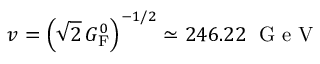Convert formula to latex. <formula><loc_0><loc_0><loc_500><loc_500>v = \left ( { \sqrt { 2 } } \, G _ { F } ^ { 0 } \right ) ^ { - 1 / 2 } \simeq 2 4 6 . 2 2 \, { G e V }</formula> 